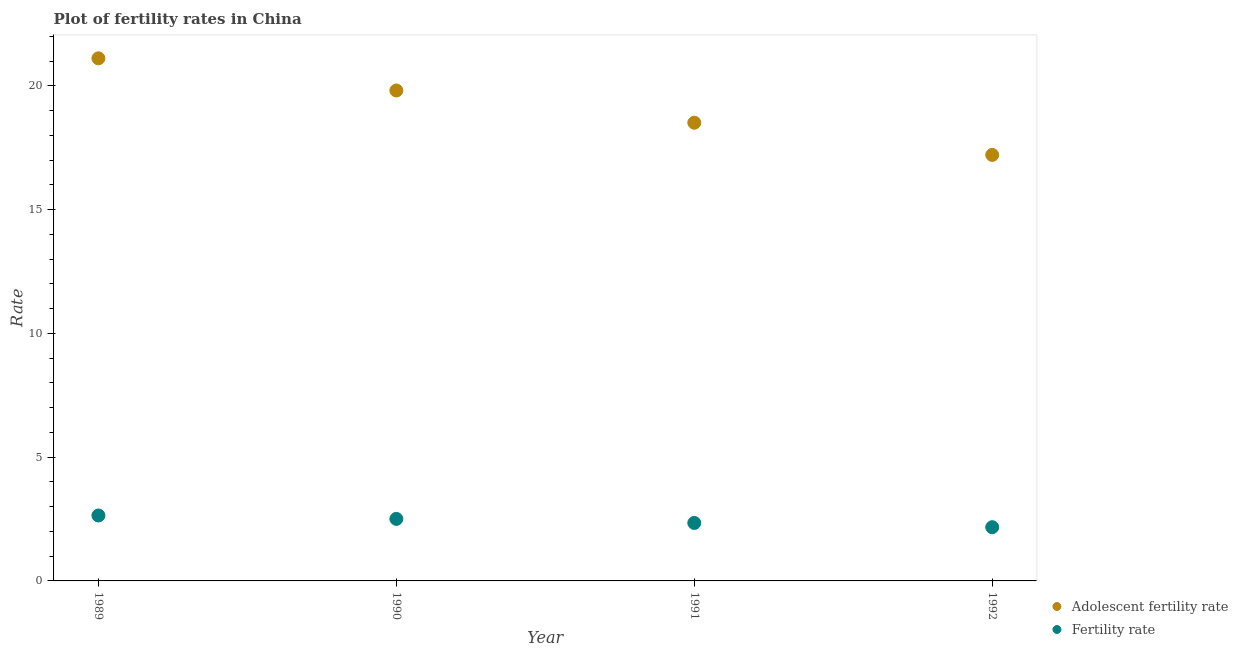How many different coloured dotlines are there?
Your answer should be compact. 2. Is the number of dotlines equal to the number of legend labels?
Your answer should be very brief. Yes. What is the fertility rate in 1991?
Offer a terse response. 2.34. Across all years, what is the maximum adolescent fertility rate?
Ensure brevity in your answer.  21.11. Across all years, what is the minimum fertility rate?
Keep it short and to the point. 2.17. In which year was the adolescent fertility rate minimum?
Make the answer very short. 1992. What is the total fertility rate in the graph?
Keep it short and to the point. 9.66. What is the difference between the adolescent fertility rate in 1990 and that in 1991?
Provide a succinct answer. 1.3. What is the difference between the adolescent fertility rate in 1992 and the fertility rate in 1991?
Provide a short and direct response. 14.87. What is the average adolescent fertility rate per year?
Provide a short and direct response. 19.16. In the year 1991, what is the difference between the fertility rate and adolescent fertility rate?
Your response must be concise. -16.17. What is the ratio of the adolescent fertility rate in 1989 to that in 1991?
Make the answer very short. 1.14. Is the fertility rate in 1989 less than that in 1992?
Offer a terse response. No. Is the difference between the adolescent fertility rate in 1989 and 1991 greater than the difference between the fertility rate in 1989 and 1991?
Provide a short and direct response. Yes. What is the difference between the highest and the second highest fertility rate?
Offer a terse response. 0.14. What is the difference between the highest and the lowest adolescent fertility rate?
Your answer should be very brief. 3.9. In how many years, is the fertility rate greater than the average fertility rate taken over all years?
Provide a succinct answer. 2. Does the fertility rate monotonically increase over the years?
Keep it short and to the point. No. Is the adolescent fertility rate strictly greater than the fertility rate over the years?
Make the answer very short. Yes. What is the difference between two consecutive major ticks on the Y-axis?
Give a very brief answer. 5. Where does the legend appear in the graph?
Make the answer very short. Bottom right. What is the title of the graph?
Provide a succinct answer. Plot of fertility rates in China. What is the label or title of the X-axis?
Offer a very short reply. Year. What is the label or title of the Y-axis?
Make the answer very short. Rate. What is the Rate in Adolescent fertility rate in 1989?
Your answer should be very brief. 21.11. What is the Rate in Fertility rate in 1989?
Offer a very short reply. 2.64. What is the Rate in Adolescent fertility rate in 1990?
Your response must be concise. 19.81. What is the Rate in Fertility rate in 1990?
Keep it short and to the point. 2.51. What is the Rate in Adolescent fertility rate in 1991?
Offer a terse response. 18.51. What is the Rate of Fertility rate in 1991?
Make the answer very short. 2.34. What is the Rate in Adolescent fertility rate in 1992?
Keep it short and to the point. 17.21. What is the Rate of Fertility rate in 1992?
Your response must be concise. 2.17. Across all years, what is the maximum Rate in Adolescent fertility rate?
Your answer should be very brief. 21.11. Across all years, what is the maximum Rate in Fertility rate?
Your answer should be very brief. 2.64. Across all years, what is the minimum Rate of Adolescent fertility rate?
Offer a very short reply. 17.21. Across all years, what is the minimum Rate in Fertility rate?
Make the answer very short. 2.17. What is the total Rate in Adolescent fertility rate in the graph?
Provide a succinct answer. 76.65. What is the total Rate in Fertility rate in the graph?
Your response must be concise. 9.66. What is the difference between the Rate of Adolescent fertility rate in 1989 and that in 1990?
Your answer should be very brief. 1.3. What is the difference between the Rate in Fertility rate in 1989 and that in 1990?
Ensure brevity in your answer.  0.14. What is the difference between the Rate of Adolescent fertility rate in 1989 and that in 1991?
Your response must be concise. 2.6. What is the difference between the Rate of Fertility rate in 1989 and that in 1991?
Your answer should be compact. 0.3. What is the difference between the Rate in Adolescent fertility rate in 1989 and that in 1992?
Give a very brief answer. 3.9. What is the difference between the Rate in Fertility rate in 1989 and that in 1992?
Your answer should be very brief. 0.47. What is the difference between the Rate in Adolescent fertility rate in 1990 and that in 1991?
Ensure brevity in your answer.  1.3. What is the difference between the Rate of Fertility rate in 1990 and that in 1991?
Your answer should be compact. 0.16. What is the difference between the Rate in Adolescent fertility rate in 1990 and that in 1992?
Offer a very short reply. 2.6. What is the difference between the Rate in Fertility rate in 1990 and that in 1992?
Your answer should be compact. 0.34. What is the difference between the Rate of Adolescent fertility rate in 1991 and that in 1992?
Your answer should be compact. 1.3. What is the difference between the Rate of Fertility rate in 1991 and that in 1992?
Make the answer very short. 0.17. What is the difference between the Rate of Adolescent fertility rate in 1989 and the Rate of Fertility rate in 1990?
Give a very brief answer. 18.61. What is the difference between the Rate of Adolescent fertility rate in 1989 and the Rate of Fertility rate in 1991?
Make the answer very short. 18.77. What is the difference between the Rate of Adolescent fertility rate in 1989 and the Rate of Fertility rate in 1992?
Provide a succinct answer. 18.94. What is the difference between the Rate of Adolescent fertility rate in 1990 and the Rate of Fertility rate in 1991?
Your answer should be very brief. 17.47. What is the difference between the Rate in Adolescent fertility rate in 1990 and the Rate in Fertility rate in 1992?
Provide a short and direct response. 17.64. What is the difference between the Rate of Adolescent fertility rate in 1991 and the Rate of Fertility rate in 1992?
Offer a terse response. 16.34. What is the average Rate of Adolescent fertility rate per year?
Your answer should be compact. 19.16. What is the average Rate in Fertility rate per year?
Keep it short and to the point. 2.42. In the year 1989, what is the difference between the Rate of Adolescent fertility rate and Rate of Fertility rate?
Offer a very short reply. 18.47. In the year 1990, what is the difference between the Rate of Adolescent fertility rate and Rate of Fertility rate?
Your answer should be very brief. 17.31. In the year 1991, what is the difference between the Rate in Adolescent fertility rate and Rate in Fertility rate?
Offer a terse response. 16.17. In the year 1992, what is the difference between the Rate in Adolescent fertility rate and Rate in Fertility rate?
Provide a succinct answer. 15.04. What is the ratio of the Rate in Adolescent fertility rate in 1989 to that in 1990?
Your answer should be compact. 1.07. What is the ratio of the Rate in Fertility rate in 1989 to that in 1990?
Offer a very short reply. 1.06. What is the ratio of the Rate of Adolescent fertility rate in 1989 to that in 1991?
Your answer should be very brief. 1.14. What is the ratio of the Rate in Fertility rate in 1989 to that in 1991?
Provide a short and direct response. 1.13. What is the ratio of the Rate of Adolescent fertility rate in 1989 to that in 1992?
Provide a succinct answer. 1.23. What is the ratio of the Rate in Fertility rate in 1989 to that in 1992?
Your answer should be compact. 1.22. What is the ratio of the Rate of Adolescent fertility rate in 1990 to that in 1991?
Your response must be concise. 1.07. What is the ratio of the Rate in Fertility rate in 1990 to that in 1991?
Offer a terse response. 1.07. What is the ratio of the Rate of Adolescent fertility rate in 1990 to that in 1992?
Provide a succinct answer. 1.15. What is the ratio of the Rate of Fertility rate in 1990 to that in 1992?
Offer a very short reply. 1.15. What is the ratio of the Rate in Adolescent fertility rate in 1991 to that in 1992?
Give a very brief answer. 1.08. What is the ratio of the Rate of Fertility rate in 1991 to that in 1992?
Provide a succinct answer. 1.08. What is the difference between the highest and the second highest Rate in Adolescent fertility rate?
Give a very brief answer. 1.3. What is the difference between the highest and the second highest Rate of Fertility rate?
Give a very brief answer. 0.14. What is the difference between the highest and the lowest Rate of Adolescent fertility rate?
Provide a short and direct response. 3.9. What is the difference between the highest and the lowest Rate in Fertility rate?
Provide a succinct answer. 0.47. 